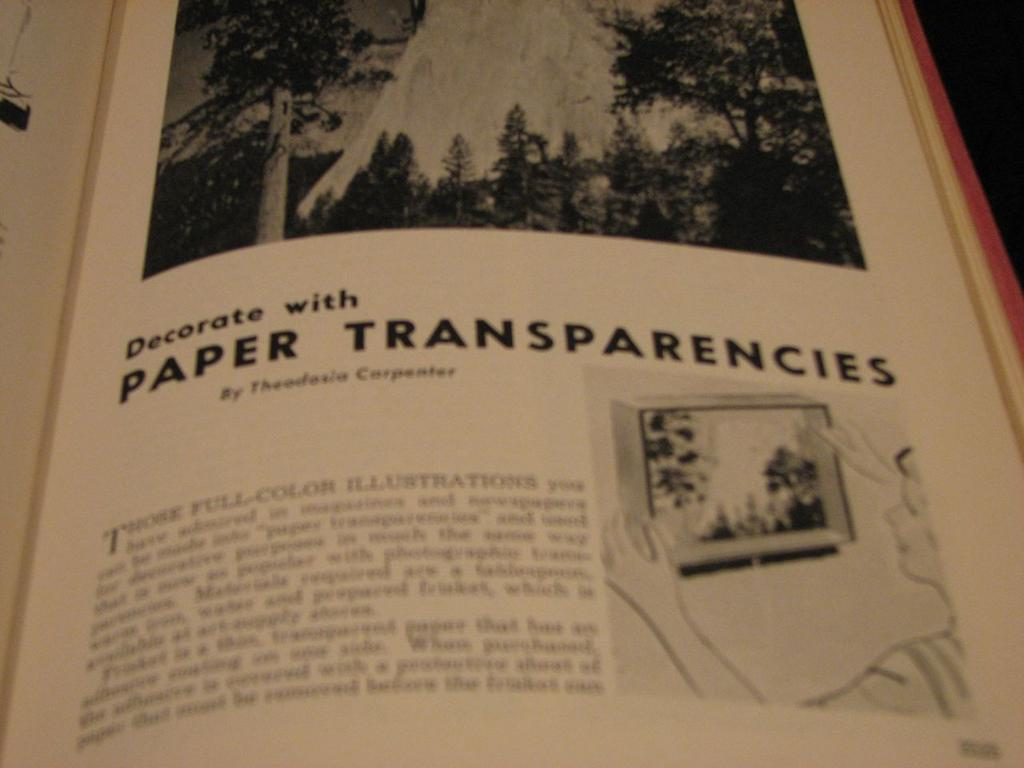<image>
Write a terse but informative summary of the picture. A text book describes decorating with paper transparencies. 